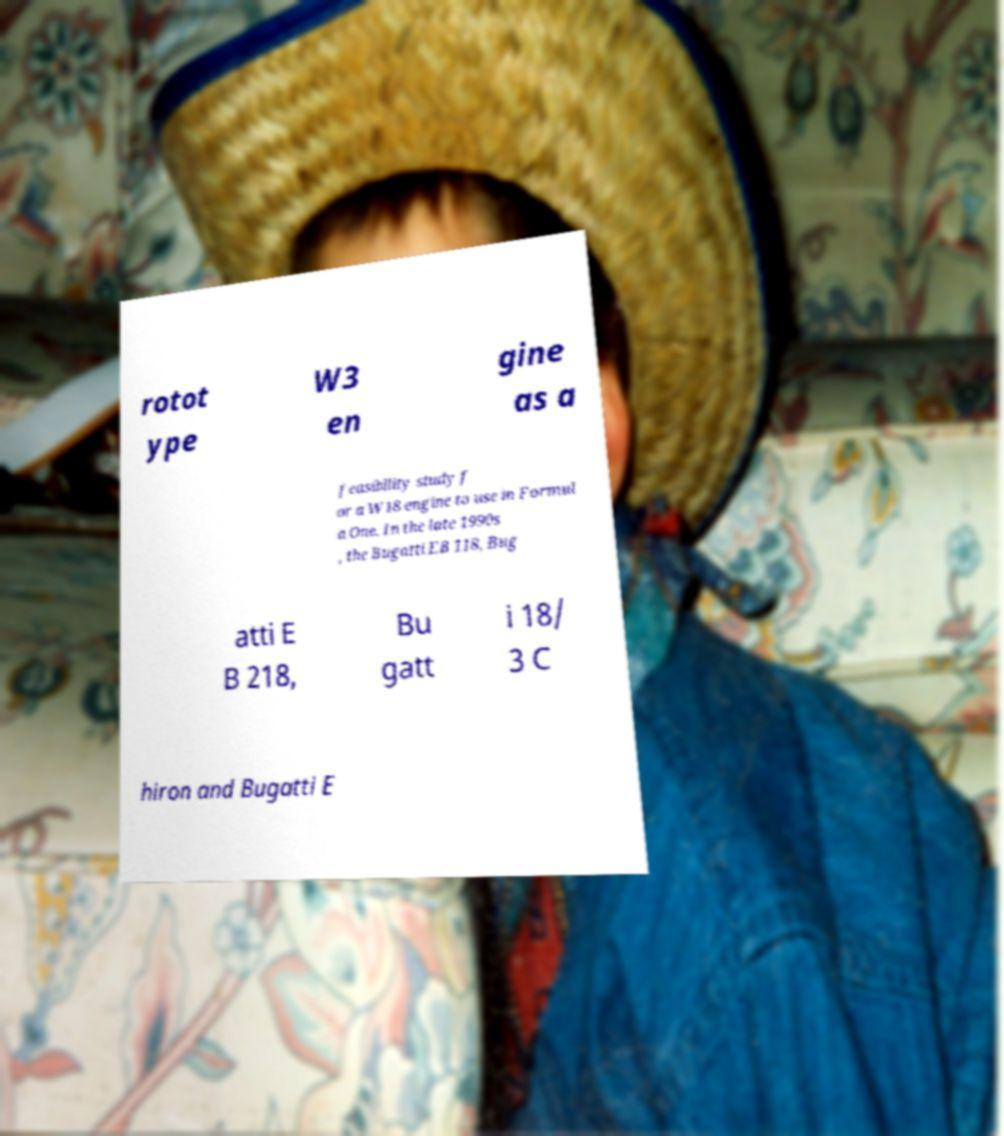Please identify and transcribe the text found in this image. rotot ype W3 en gine as a feasibility study f or a W18 engine to use in Formul a One. In the late 1990s , the Bugatti EB 118, Bug atti E B 218, Bu gatt i 18/ 3 C hiron and Bugatti E 